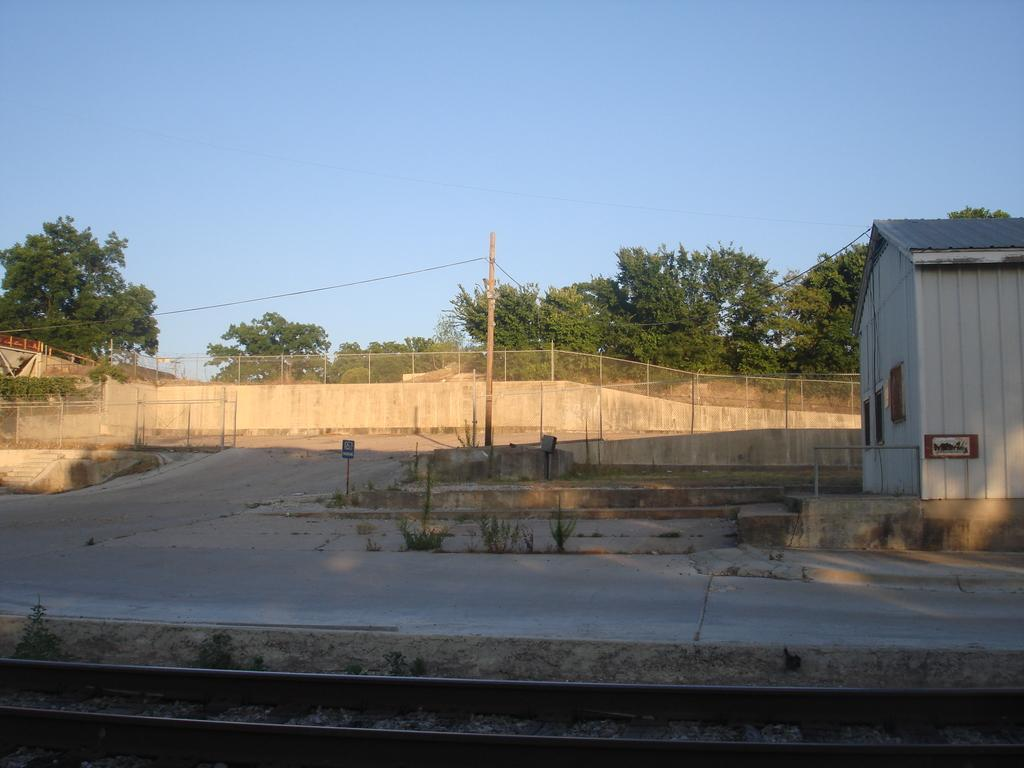What type of transportation infrastructure is visible in the image? There is a train track in the image. What type of vegetation can be seen in the image? There are plants and trees in the image. What type of structure is present in the image? There is a pole and a house in the image. What type of architectural feature is visible in the image? There are railings in the image. What part of the natural environment is visible in the image? The sky is visible in the image. How many types of vegetation can be seen in the image? There are two types of vegetation: plants and trees. What type of need is being met by the ice in the image? There is no ice present in the image, so this question cannot be answered. What type of achievement is represented by the house in the image? The image does not convey any information about the house representing an achievement, so this question cannot be answered. 